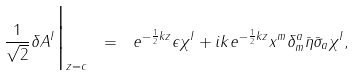<formula> <loc_0><loc_0><loc_500><loc_500>\frac { 1 } { \sqrt { 2 } } \delta A ^ { I } \Big | _ { z = c } \ = \ e ^ { - \frac { 1 } { 2 } k z } \epsilon \chi ^ { I } + i k e ^ { - \frac { 1 } { 2 } k z } x ^ { m } \delta ^ { a } _ { m } \bar { \eta } \bar { \sigma } _ { a } \chi ^ { I } ,</formula> 